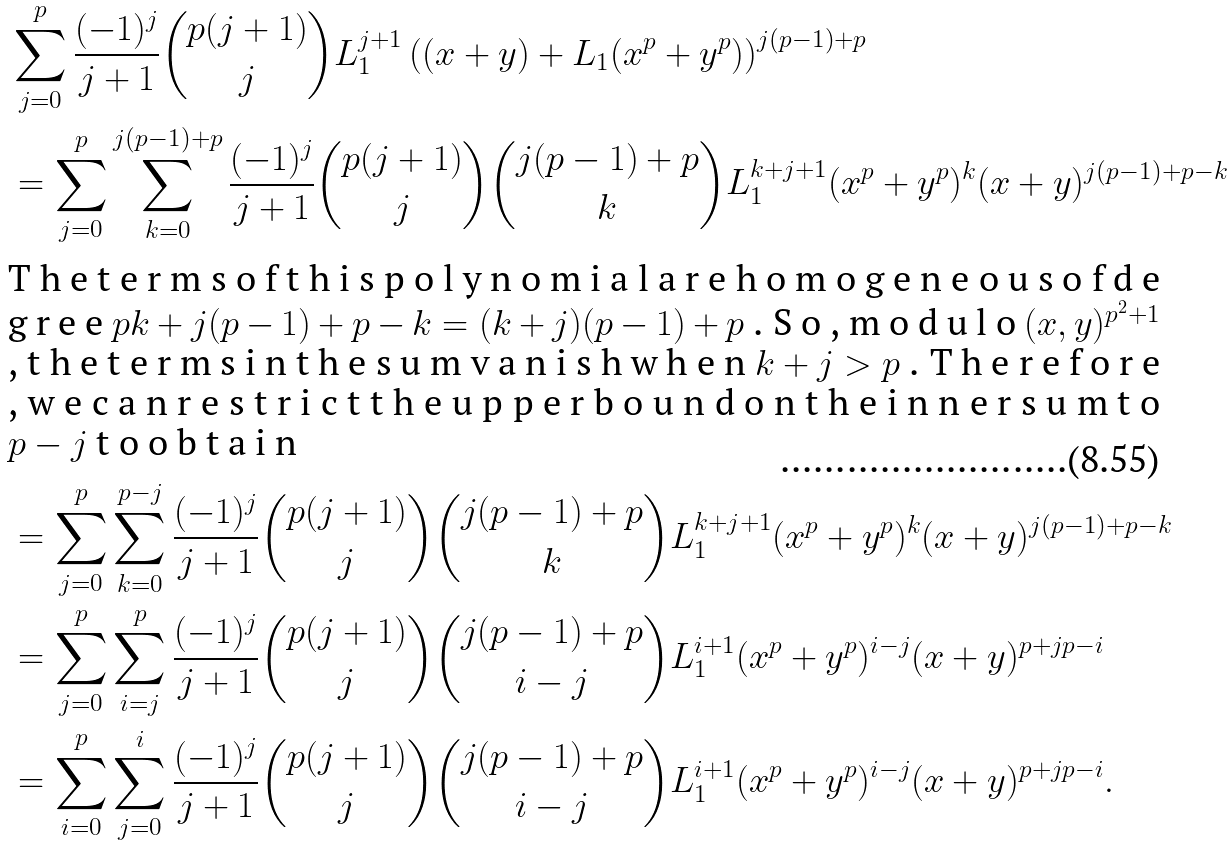<formula> <loc_0><loc_0><loc_500><loc_500>& \sum _ { j = 0 } ^ { p } \frac { ( - 1 ) ^ { j } } { j + 1 } \binom { p ( j + 1 ) } { j } L _ { 1 } ^ { j + 1 } \left ( ( x + y ) + L _ { 1 } ( x ^ { p } + y ^ { p } ) \right ) ^ { j ( p - 1 ) + p } \\ & = \sum _ { j = 0 } ^ { p } \sum _ { k = 0 } ^ { j ( p - 1 ) + p } \frac { ( - 1 ) ^ { j } } { j + 1 } \binom { p ( j + 1 ) } { j } \binom { j ( p - 1 ) + p } { k } L _ { 1 } ^ { k + j + 1 } ( x ^ { p } + y ^ { p } ) ^ { k } ( x + y ) ^ { j ( p - 1 ) + p - k } \\ \intertext { T h e t e r m s o f t h i s p o l y n o m i a l a r e h o m o g e n e o u s o f d e g r e e $ p k + j ( p - 1 ) + p - k = ( k + j ) ( p - 1 ) + p $ . S o , m o d u l o $ ( x , y ) ^ { p ^ { 2 } + 1 } $ , t h e t e r m s i n t h e s u m v a n i s h w h e n $ k + j > p $ . T h e r e f o r e , w e c a n r e s t r i c t t h e u p p e r b o u n d o n t h e i n n e r s u m t o $ p - j $ t o o b t a i n } & = \sum _ { j = 0 } ^ { p } \sum _ { k = 0 } ^ { p - j } \frac { ( - 1 ) ^ { j } } { j + 1 } \binom { p ( j + 1 ) } { j } \binom { j ( p - 1 ) + p } { k } L _ { 1 } ^ { k + j + 1 } ( x ^ { p } + y ^ { p } ) ^ { k } ( x + y ) ^ { j ( p - 1 ) + p - k } \\ & = \sum _ { j = 0 } ^ { p } \sum _ { i = j } ^ { p } \frac { ( - 1 ) ^ { j } } { j + 1 } \binom { p ( j + 1 ) } { j } \binom { j ( p - 1 ) + p } { i - j } L _ { 1 } ^ { i + 1 } ( x ^ { p } + y ^ { p } ) ^ { i - j } ( x + y ) ^ { p + j p - i } \\ & = \sum _ { i = 0 } ^ { p } \sum _ { j = 0 } ^ { i } \frac { ( - 1 ) ^ { j } } { j + 1 } \binom { p ( j + 1 ) } { j } \binom { j ( p - 1 ) + p } { i - j } L _ { 1 } ^ { i + 1 } ( x ^ { p } + y ^ { p } ) ^ { i - j } ( x + y ) ^ { p + j p - i } .</formula> 